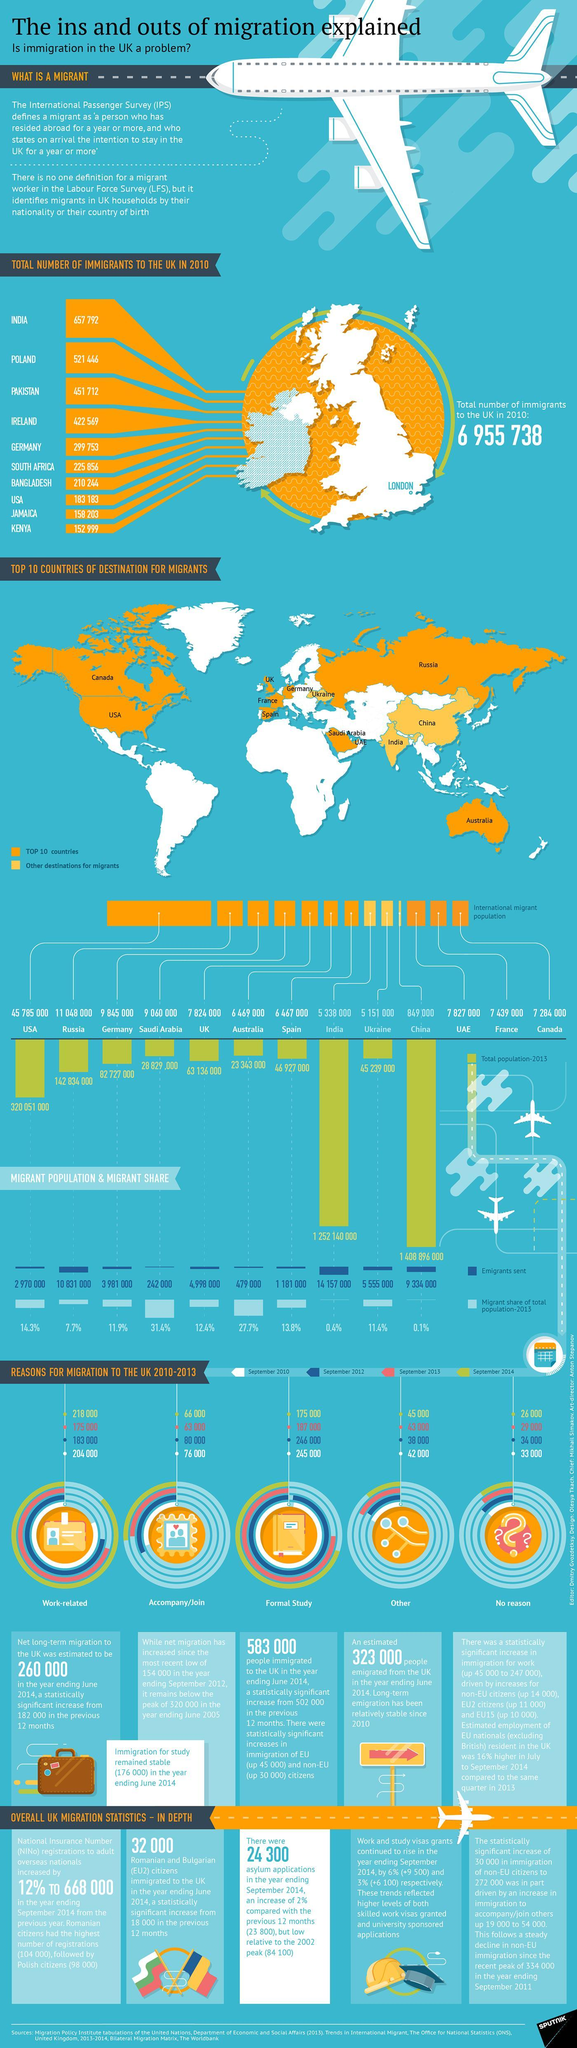How many people migrated to UK for no reason in September 2014?
Answer the question with a short phrase. 26 000 How many people migrated to UK for work-related purpose in September 2012? 183 000 What is the migrant share of total population in Australia in 2013? 27.7% How many emigrants were sent to China in 2013? 9 334 000 Which country has the second largest International migrant population in 2013? Russia How many people migrated to UK as an accompanying person in September 2014? 66 000 Which country has the least International migrant population in 2013? China Which country has the largest International migrant population in 2013? USA How many people migrated to UK for formal studies in September 2010? 245 000 What is the migrant share of total population in India in 2013? 0.4% 